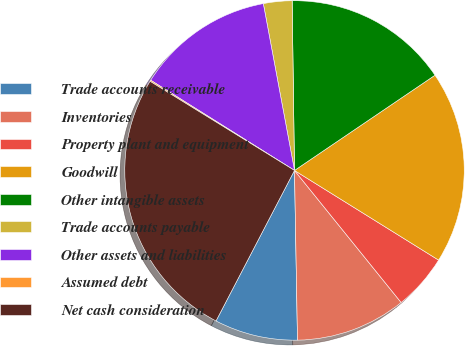<chart> <loc_0><loc_0><loc_500><loc_500><pie_chart><fcel>Trade accounts receivable<fcel>Inventories<fcel>Property plant and equipment<fcel>Goodwill<fcel>Other intangible assets<fcel>Trade accounts payable<fcel>Other assets and liabilities<fcel>Assumed debt<fcel>Net cash consideration<nl><fcel>7.93%<fcel>10.53%<fcel>5.33%<fcel>18.34%<fcel>15.74%<fcel>2.72%<fcel>13.14%<fcel>0.12%<fcel>26.15%<nl></chart> 